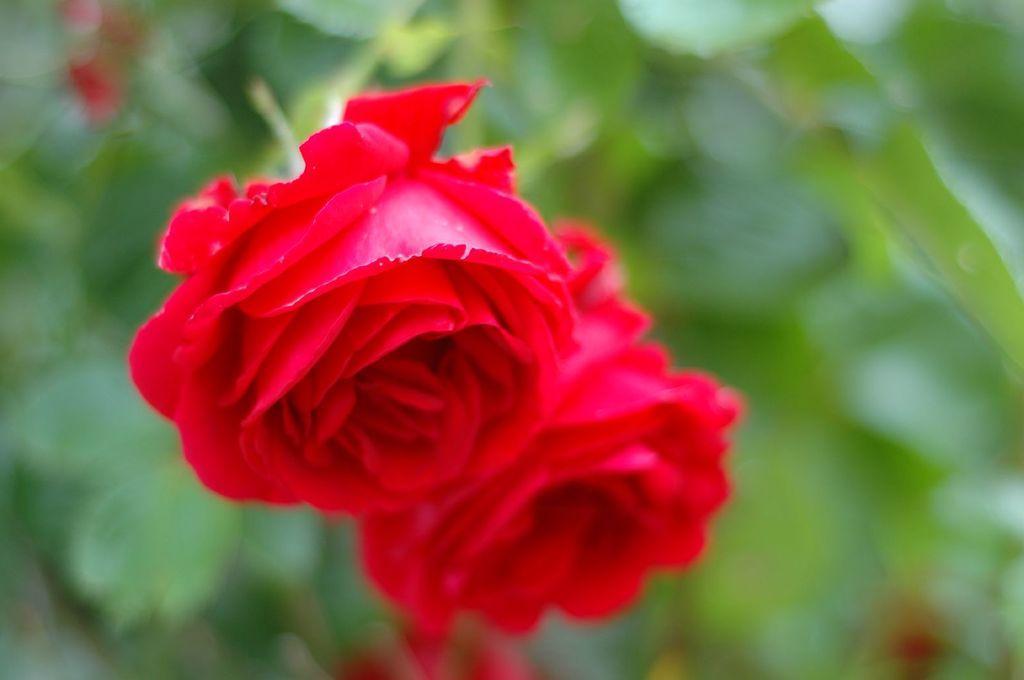Please provide a concise description of this image. In this image there are two rose flowers, in the background it is blurred. 